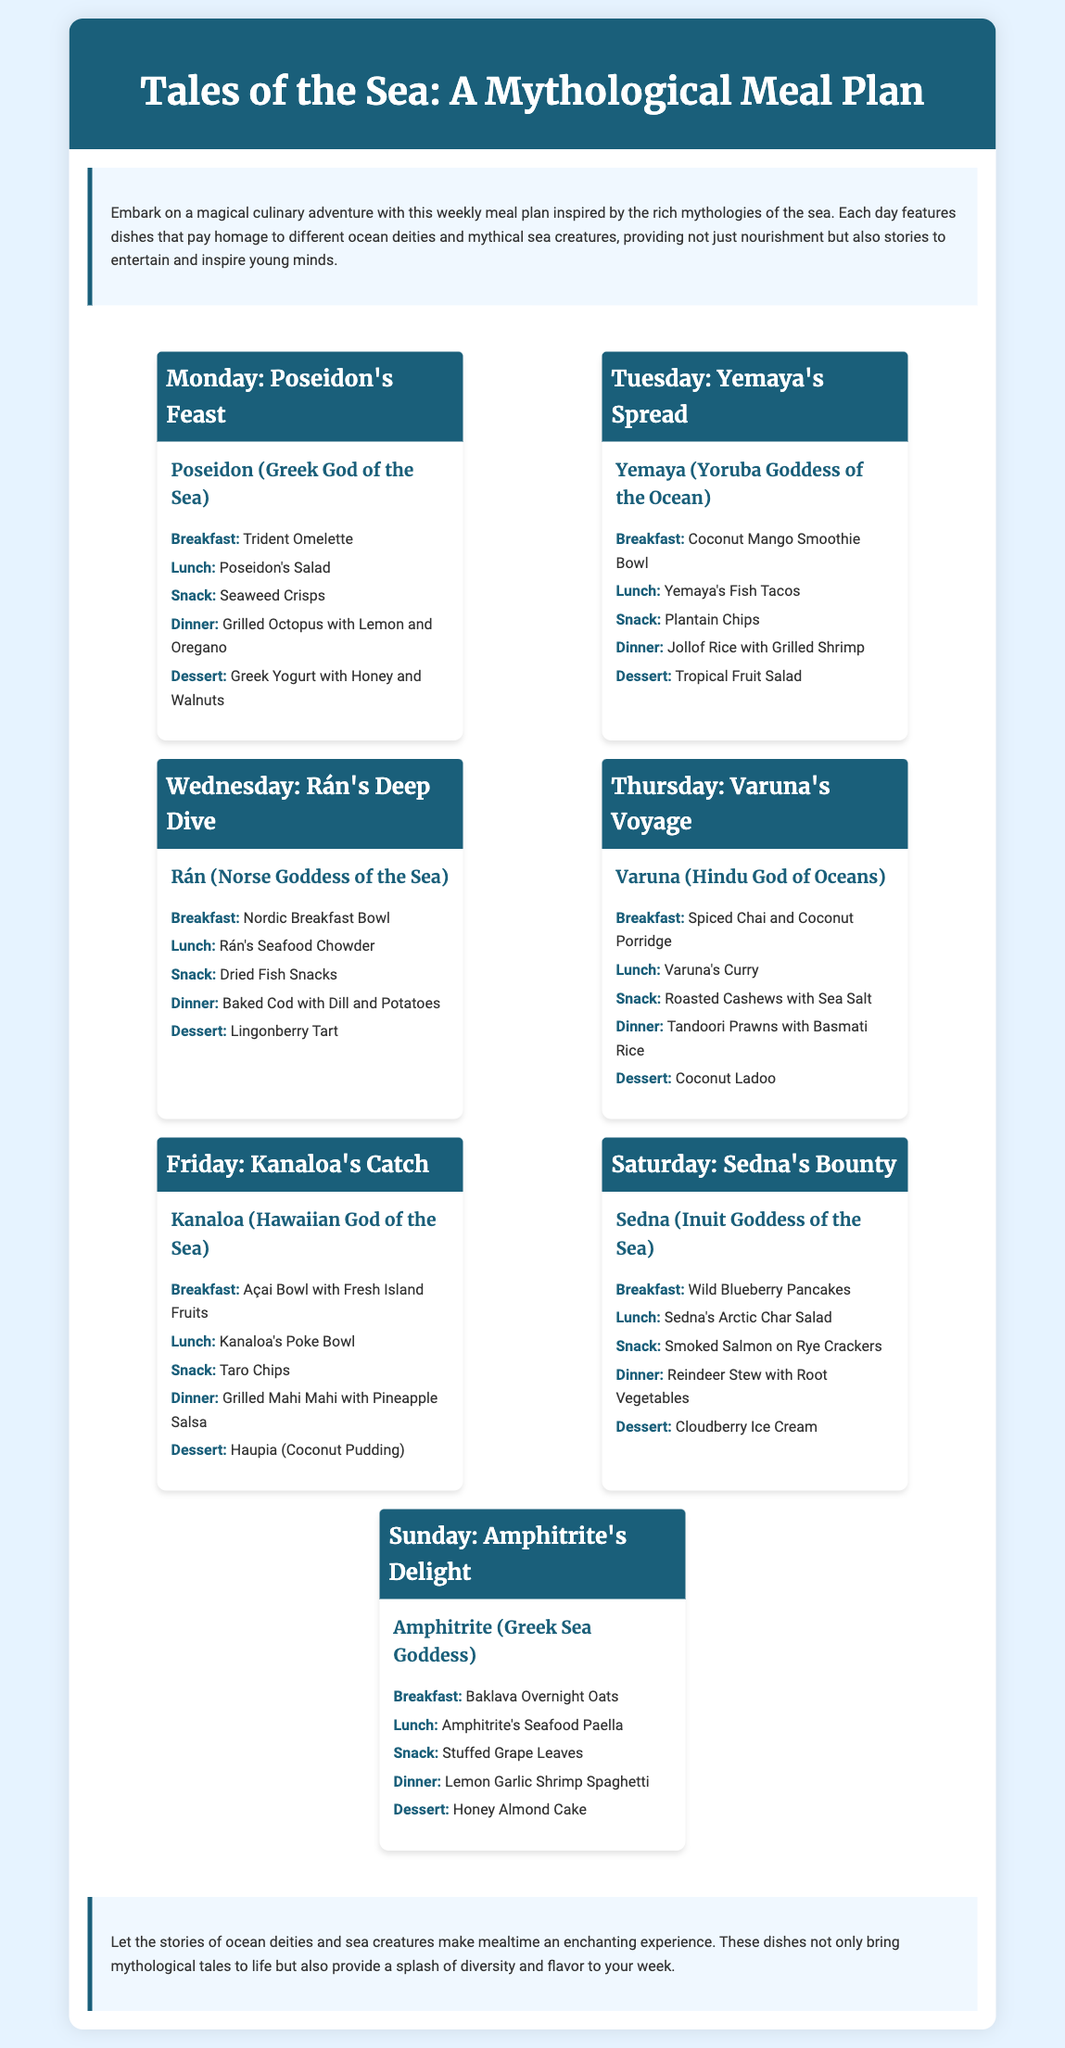What is the title of the meal plan? The title of the meal plan is prominently displayed at the top of the document.
Answer: Tales of the Sea: A Mythological Meal Plan Which day features Yemaya's Spread? The meal plan lists each day along with the corresponding theme at the start of each day card.
Answer: Tuesday What is served for dinner on Friday? Each day card outlines specific meals for breakfast, lunch, snack, dinner, and dessert.
Answer: Grilled Mahi Mahi with Pineapple Salsa How many different ocean deities are featured in the meal plan? The meal plan includes a variety of ocean deities, each representing a different day, and their names are listed under their respective days.
Answer: Seven What type of dessert is served on Saturday? Each day's meal listing includes a dessert, specifically highlighted at the end of each day card.
Answer: Cloudberry Ice Cream What ingredient is common in the breakfasts for Poseidon's Feast and Amphitrite's Delight? Comparing the breakfasts listed for the two days reveals shared ingredients found in both dishes.
Answer: Oats 